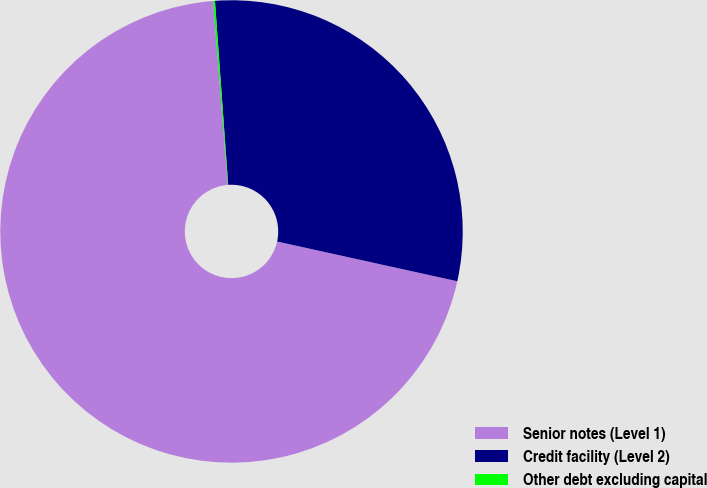<chart> <loc_0><loc_0><loc_500><loc_500><pie_chart><fcel>Senior notes (Level 1)<fcel>Credit facility (Level 2)<fcel>Other debt excluding capital<nl><fcel>70.28%<fcel>29.6%<fcel>0.13%<nl></chart> 